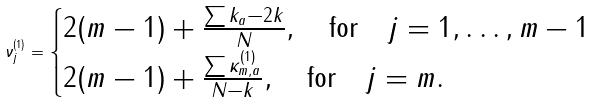<formula> <loc_0><loc_0><loc_500><loc_500>\nu _ { j } ^ { ( 1 ) } = \begin{cases} 2 ( m - 1 ) + \frac { \sum k _ { a } - 2 k } { N } , \quad \text {for} \quad j = 1 , \dots , m - 1 \\ 2 ( m - 1 ) + \frac { \sum \kappa _ { m , a } ^ { ( 1 ) } } { N - k } , \quad \text {for} \quad j = m . \end{cases}</formula> 